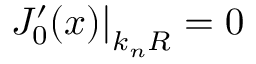Convert formula to latex. <formula><loc_0><loc_0><loc_500><loc_500>J _ { 0 } ^ { \prime } ( x ) \right | _ { k _ { n } R } = 0</formula> 